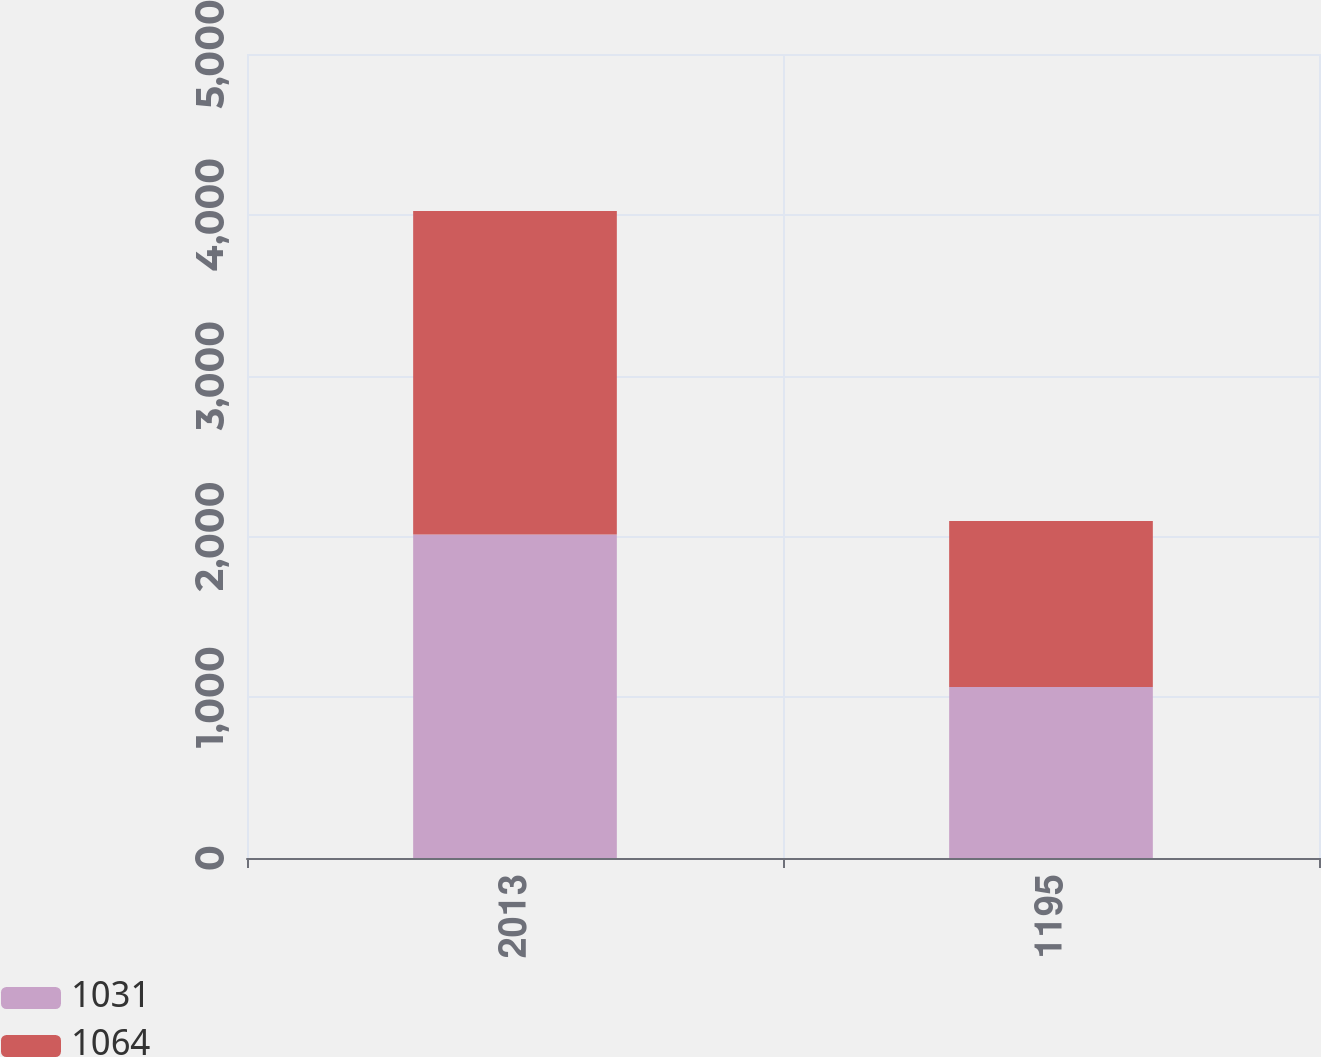Convert chart to OTSL. <chart><loc_0><loc_0><loc_500><loc_500><stacked_bar_chart><ecel><fcel>2013<fcel>1195<nl><fcel>1031<fcel>2012<fcel>1064<nl><fcel>1064<fcel>2011<fcel>1031<nl></chart> 